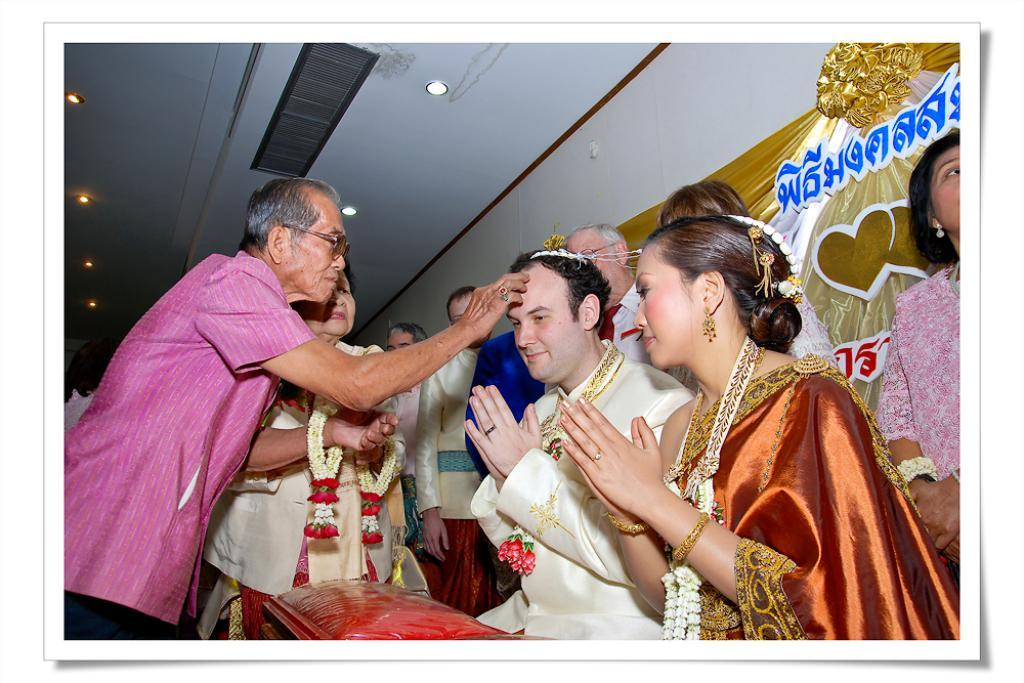How many people are in the image? There are persons in the image, but the exact number is not specified. What is attached to the wall on the right side of the image? There is a design banner attached to the wall on the right side. What is visible at the top of the image? At the top of the image, there is a roof. What can be seen on the roof? On the roof, there are lights visible. What type of music can be heard playing in the background of the image? There is no information about music or any sounds in the image, so it cannot be determined from the picture. 